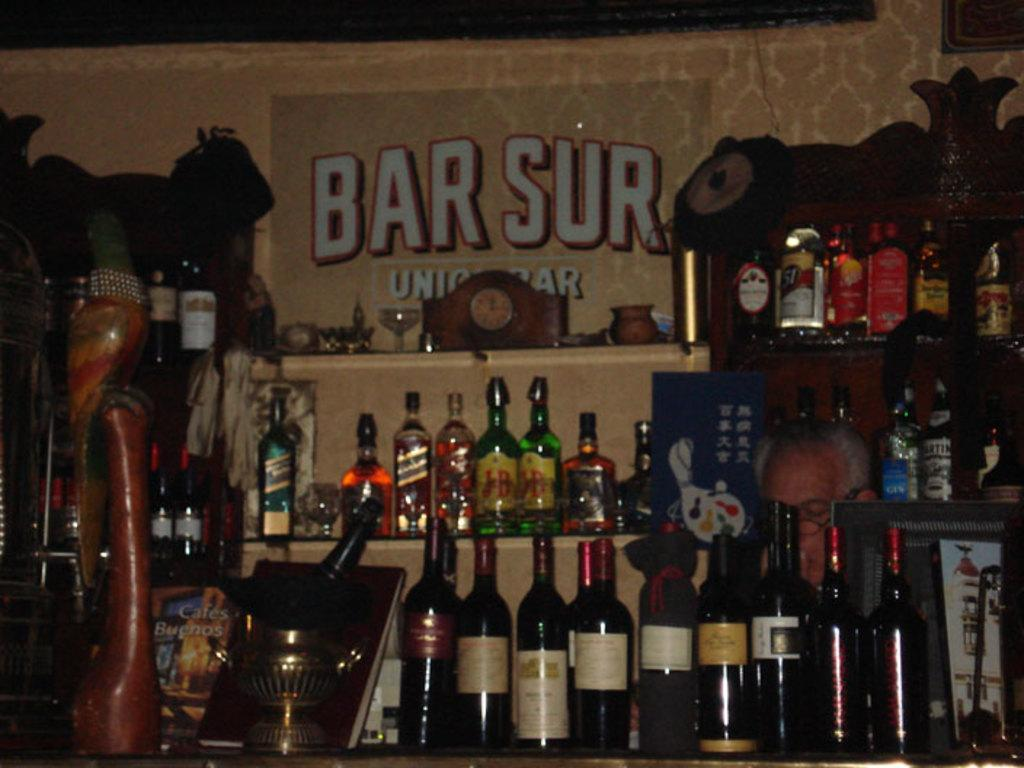<image>
Provide a brief description of the given image. The shelves in Bar Sur shows many bottles of all types of liquor. 